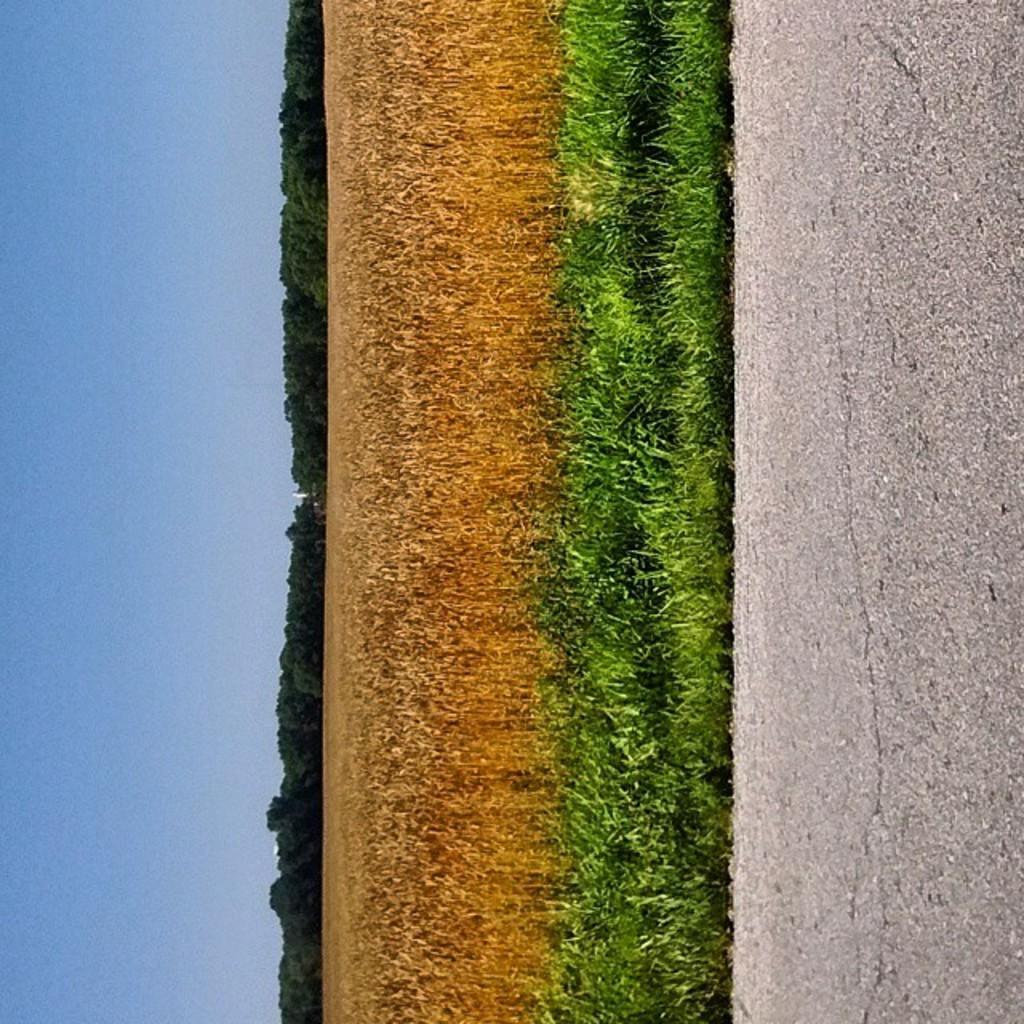Can you describe this image briefly? In front of the image there is a road, behind the road there is green grass, behind the grass there is dry crop, behind that there are trees. 